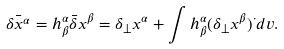Convert formula to latex. <formula><loc_0><loc_0><loc_500><loc_500>\bar { \delta x ^ { \alpha } } = h ^ { \alpha } _ { \beta } \bar { \delta } x ^ { \beta } = \delta _ { \bot } x ^ { \alpha } + \int h ^ { \alpha } _ { \beta } ( \delta _ { \bot } x ^ { \beta } ) ^ { \cdot } d v .</formula> 